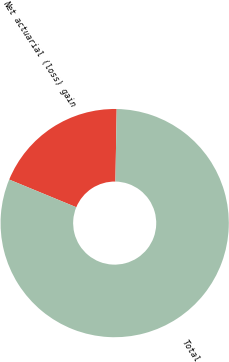Convert chart to OTSL. <chart><loc_0><loc_0><loc_500><loc_500><pie_chart><fcel>Net actuarial (loss) gain<fcel>Total<nl><fcel>19.05%<fcel>80.95%<nl></chart> 